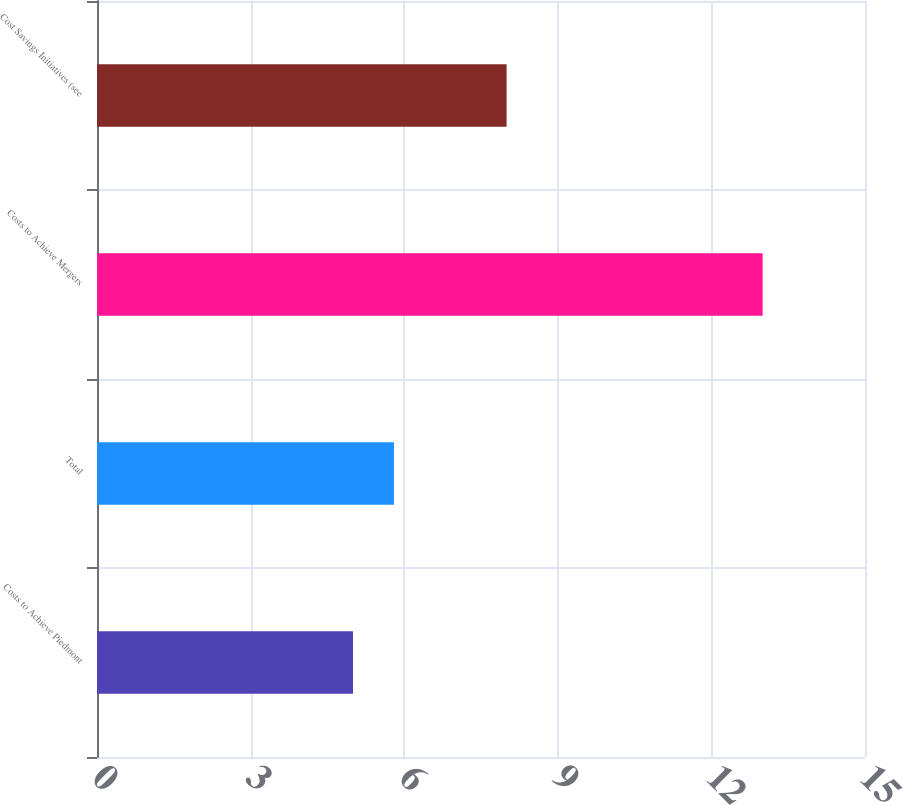Convert chart to OTSL. <chart><loc_0><loc_0><loc_500><loc_500><bar_chart><fcel>Costs to Achieve Piedmont<fcel>Total<fcel>Costs to Achieve Mergers<fcel>Cost Savings Initiatives (see<nl><fcel>5<fcel>5.8<fcel>13<fcel>8<nl></chart> 